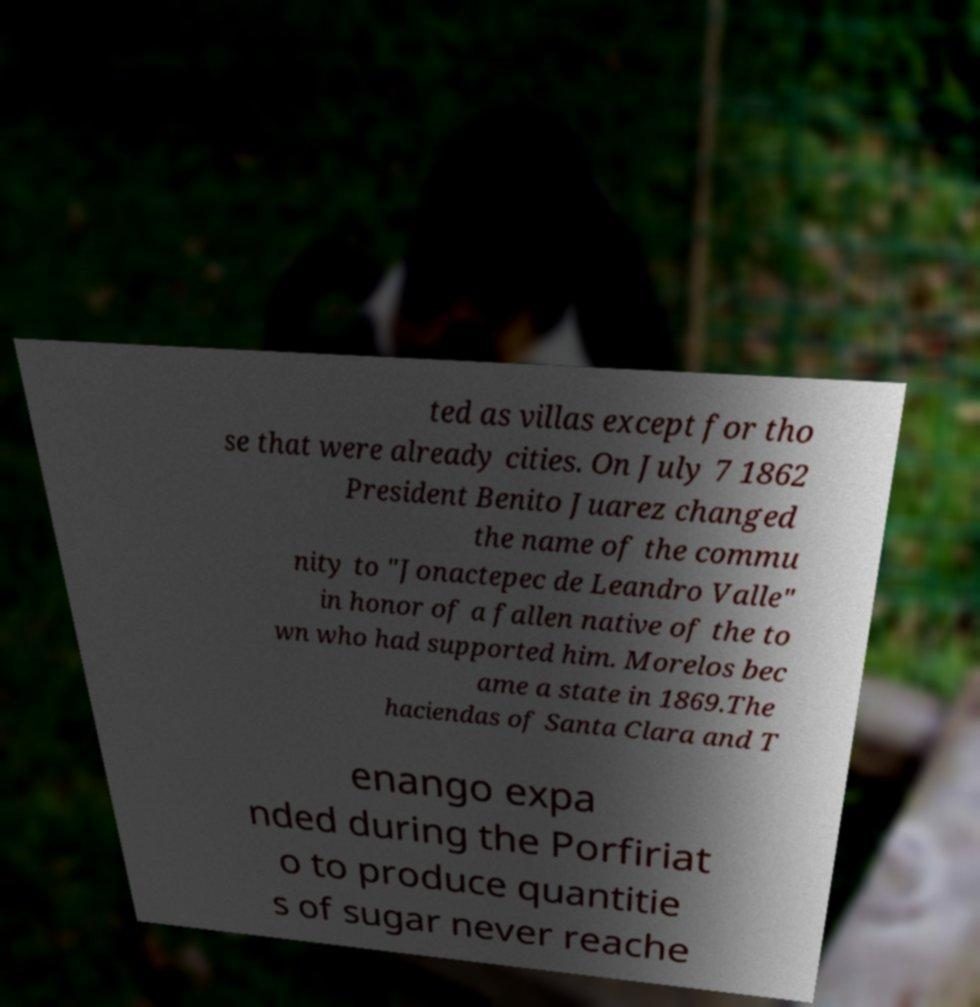What messages or text are displayed in this image? I need them in a readable, typed format. ted as villas except for tho se that were already cities. On July 7 1862 President Benito Juarez changed the name of the commu nity to "Jonactepec de Leandro Valle" in honor of a fallen native of the to wn who had supported him. Morelos bec ame a state in 1869.The haciendas of Santa Clara and T enango expa nded during the Porfiriat o to produce quantitie s of sugar never reache 